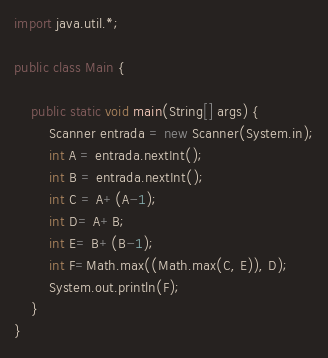<code> <loc_0><loc_0><loc_500><loc_500><_Java_>import java.util.*;

public class Main {

    public static void main(String[] args) {
        Scanner entrada = new Scanner(System.in);
        int A = entrada.nextInt();
        int B = entrada.nextInt();
        int C = A+(A-1);
        int D= A+B;
        int E= B+(B-1);
        int F=Math.max((Math.max(C, E)), D);
        System.out.println(F);
    }
}
</code> 